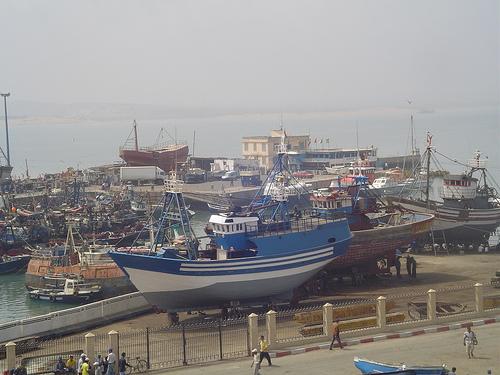Is the boat in the water?
Answer briefly. No. Is it overcast?
Concise answer only. Yes. Is this a slide?
Keep it brief. No. Are all the boats at dock?
Write a very short answer. Yes. Is there anyone on the pier?
Keep it brief. Yes. How many people are standing under the red boat?
Give a very brief answer. 3. Is this an indoor exhibit?
Concise answer only. No. Is this a busy harbor?
Be succinct. Yes. Where is the big ship?
Give a very brief answer. Dry dock. 